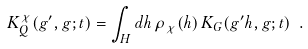<formula> <loc_0><loc_0><loc_500><loc_500>K _ { Q } ^ { \chi } ( g ^ { \prime } , g ; t ) = \int _ { H } d h \, \rho _ { \chi } ( h ) \, K _ { G } ( g ^ { \prime } h , g ; t ) \ .</formula> 